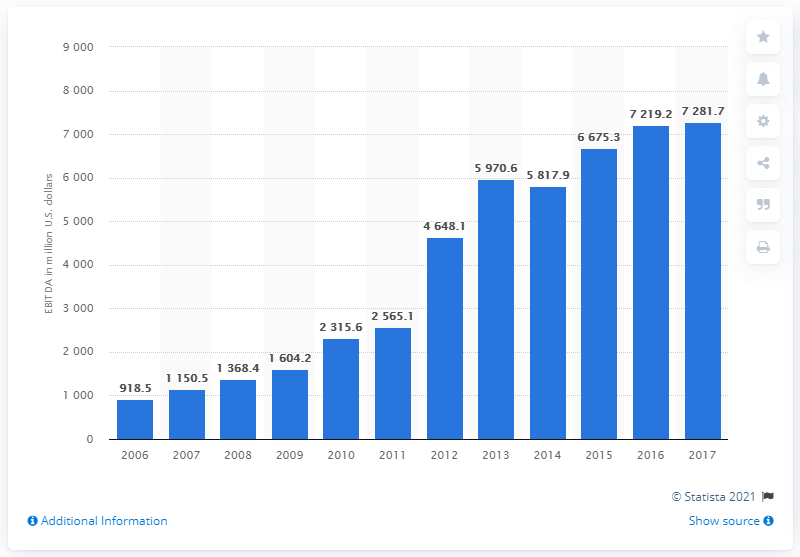Point out several critical features in this image. In 2008, Express Scripts' EBITDA (earnings before interest, taxes, depreciation, and amortization) was 1,368.4. 